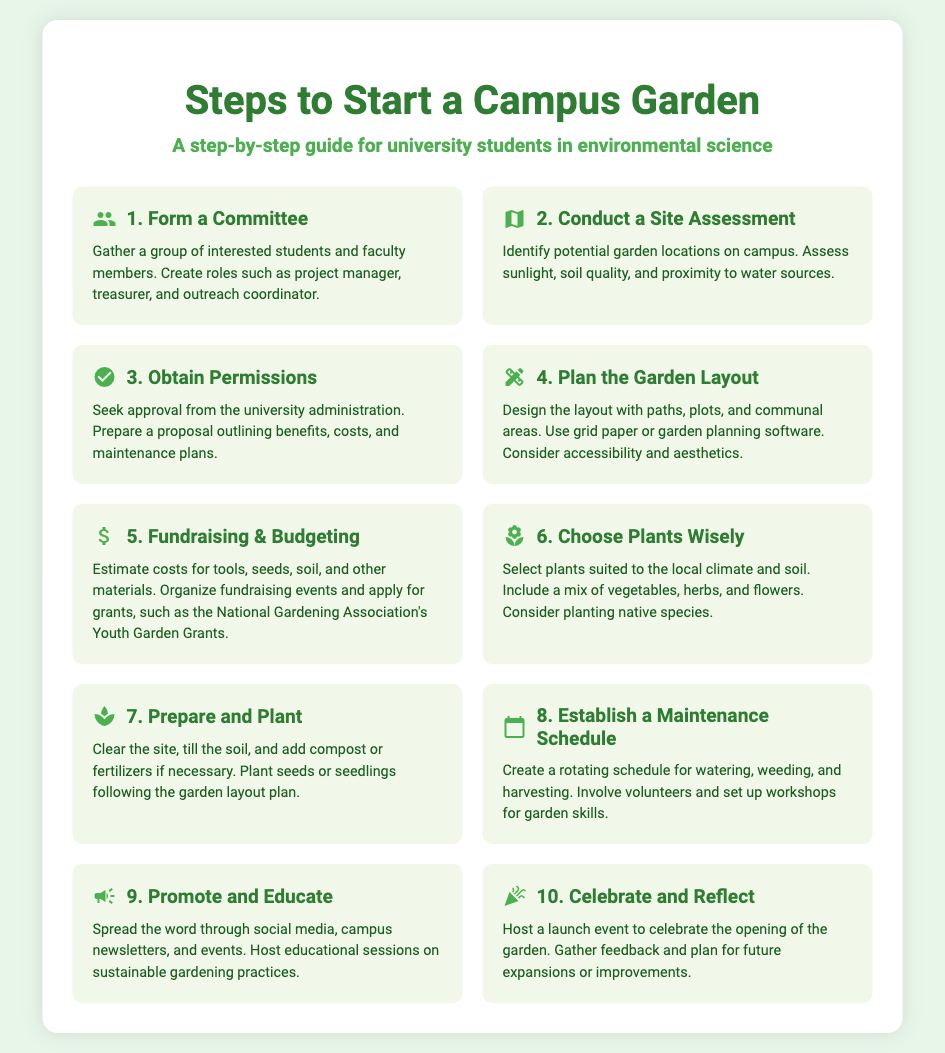what is the first step to start a campus garden? The first step is to form a committee consisting of interested students and faculty members.
Answer: Form a Committee how many steps are there to start a campus garden? The document outlines a total of 10 steps for starting a campus garden.
Answer: 10 steps what is one aspect to evaluate during a site assessment? During a site assessment, one must evaluate sunlight, soil quality, and proximity to water sources.
Answer: Sunlight name one type of plant mentioned that should be chosen wisely. The document mentions selecting vegetables, herbs, and flowers as suitable plants.
Answer: Vegetables what is the purpose of the maintenance schedule? The purpose of the maintenance schedule is to create a rotating plan for watering, weeding, and harvesting.
Answer: Rotating schedule which step involves fundraising and budgeting? Step 5 specifically focuses on fundraising and budgeting for the garden project.
Answer: Fundraising & Budgeting what should be done during the "Prepare and Plant" step? This step involves clearing the site, tilling the soil, and planting seeds or seedlings.
Answer: Clear the site, till the soil what is recommended to promote and educate about the garden? Promoting the garden can be done through social media, campus newsletters, and events.
Answer: Social media what type of event should be hosted at the end of the garden project? A launch event should be hosted to celebrate the opening of the garden and gather feedback.
Answer: Launch event 